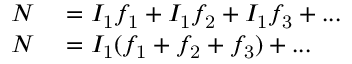<formula> <loc_0><loc_0><loc_500><loc_500>\begin{array} { r l } { N } & = I _ { 1 } f _ { 1 } + I _ { 1 } f _ { 2 } + I _ { 1 } f _ { 3 } + \dots } \\ { N } & = I _ { 1 } ( f _ { 1 } + f _ { 2 } + f _ { 3 } ) + \dots } \end{array}</formula> 